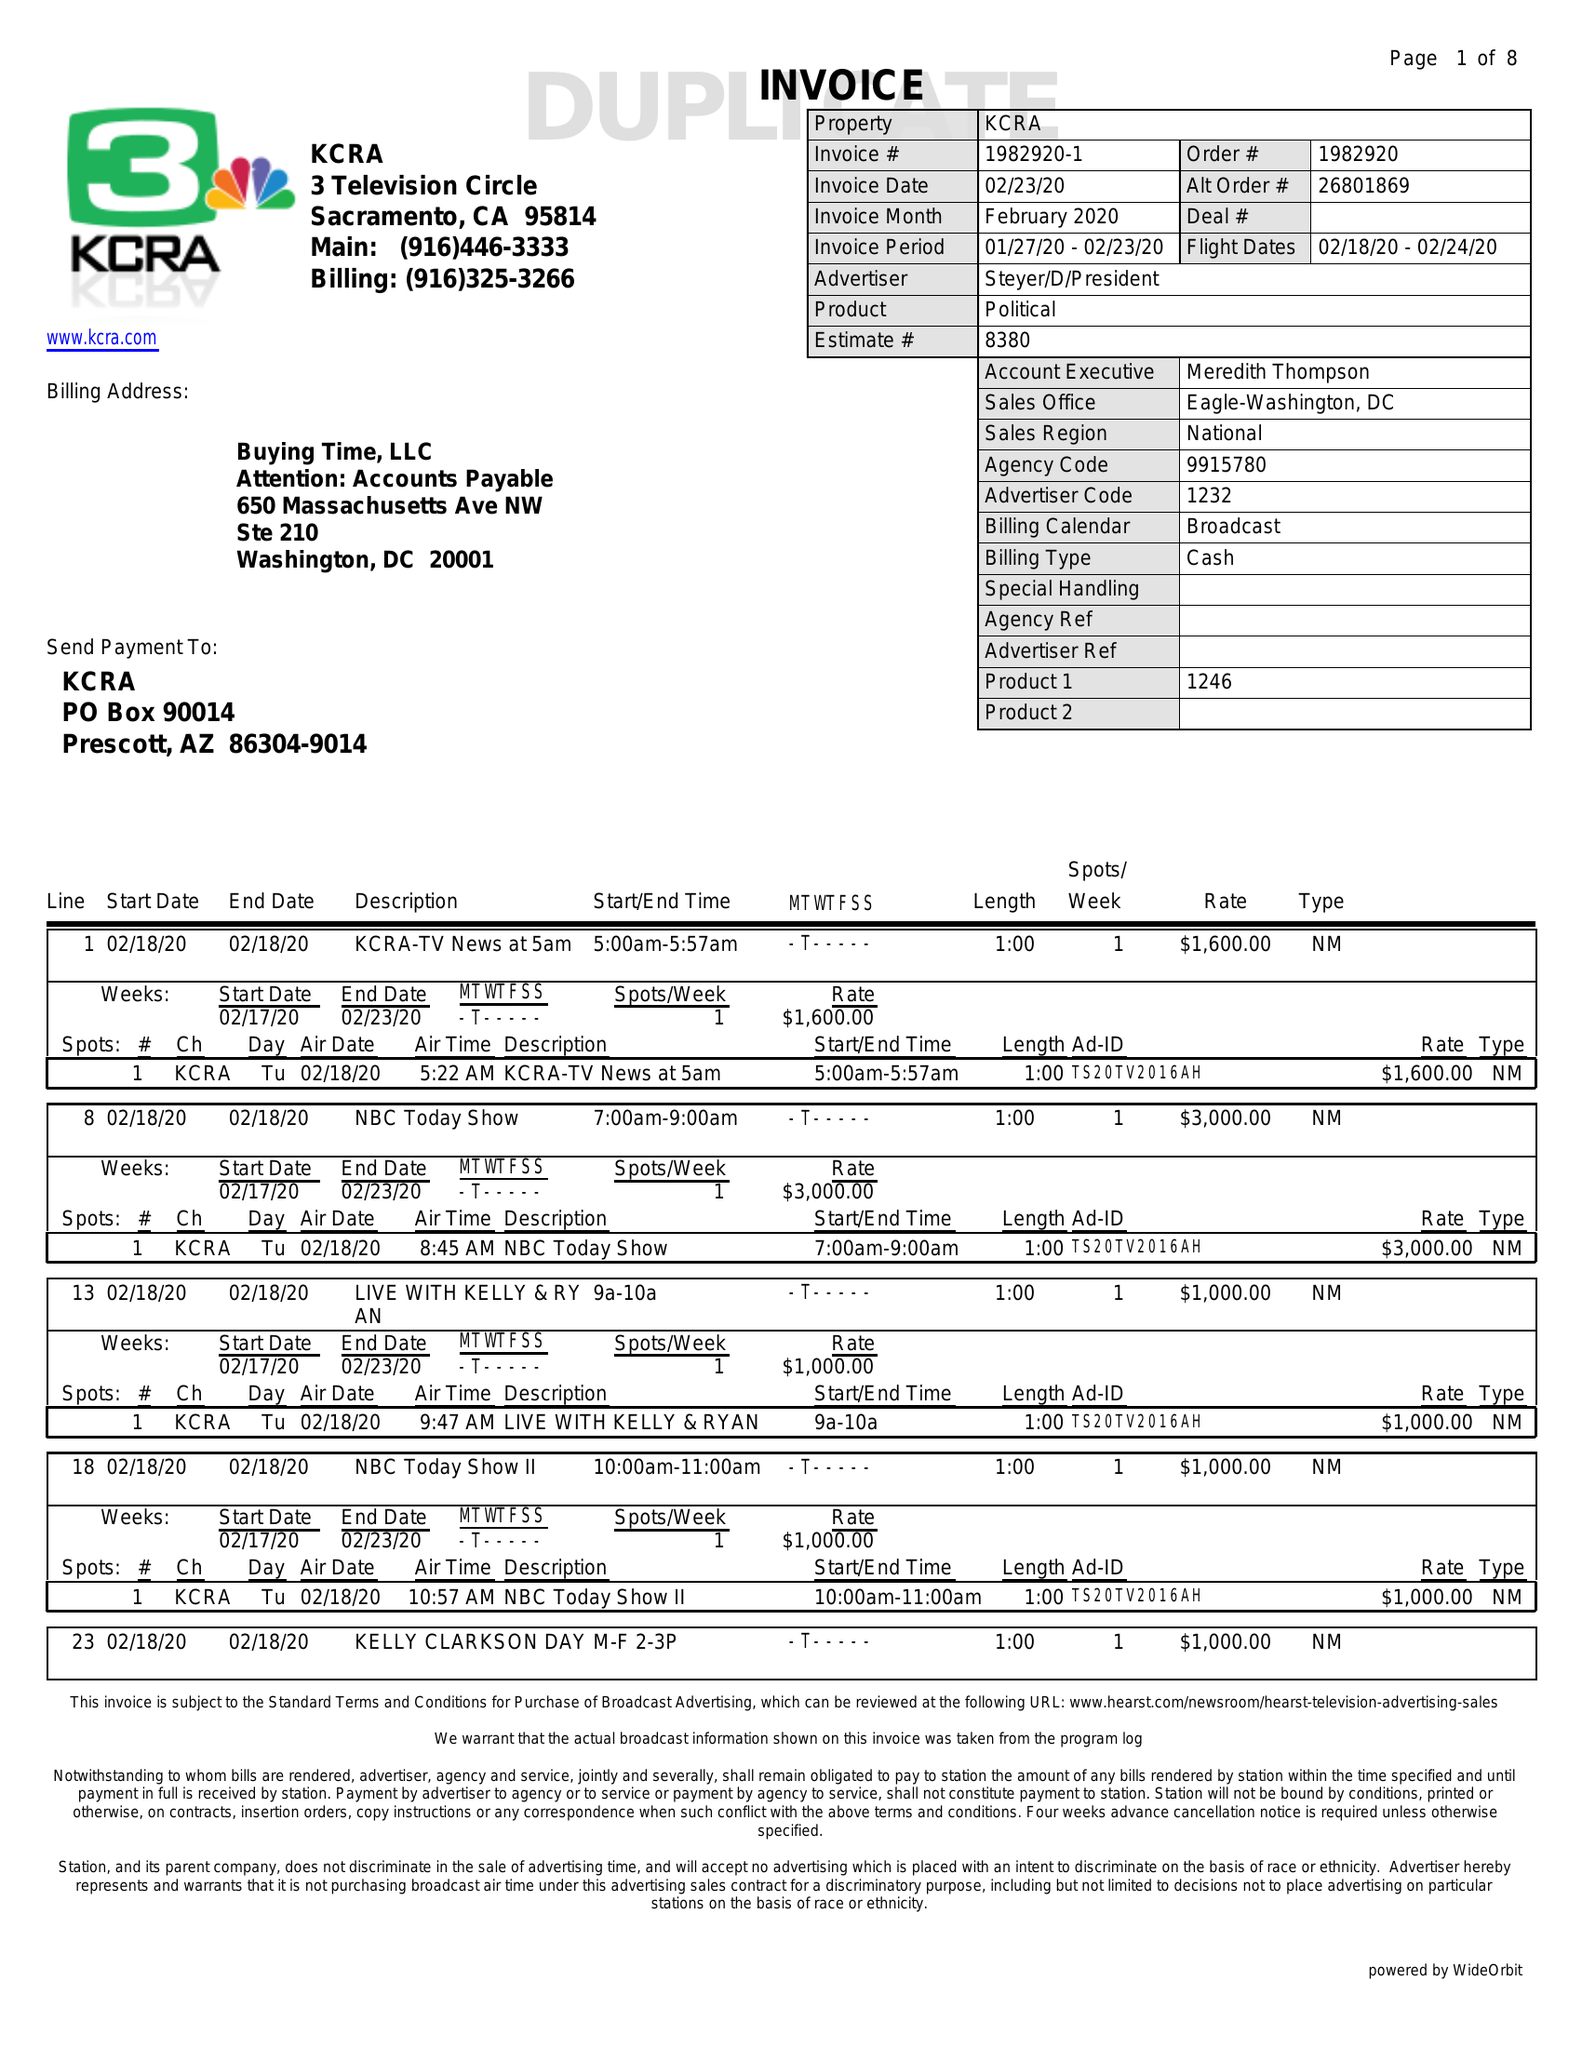What is the value for the flight_from?
Answer the question using a single word or phrase. 02/18/20 